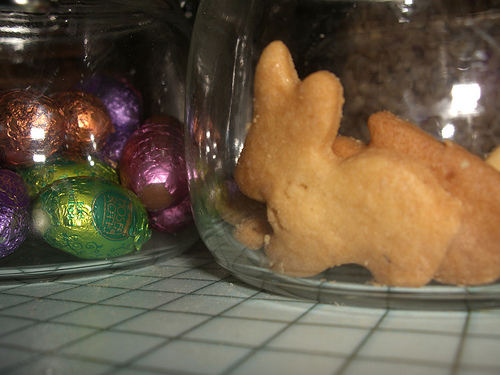<image>
Can you confirm if the cookie is on the table? Yes. Looking at the image, I can see the cookie is positioned on top of the table, with the table providing support. Is there a rabbit behind the jar? Yes. From this viewpoint, the rabbit is positioned behind the jar, with the jar partially or fully occluding the rabbit. 